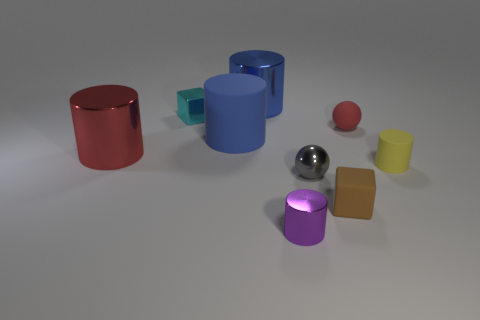What number of big objects are brown matte cubes or yellow matte things? There are no brown matte cubes or yellow matte objects of any shape among the big items in the image. The objects present include cylinders, cubes, and spheres in various colors such as red, blue, silver, and purple, but none are brown or yellow. 